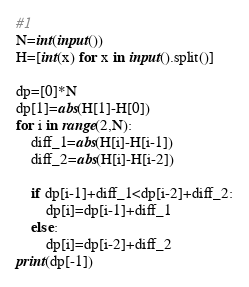<code> <loc_0><loc_0><loc_500><loc_500><_Python_>#1
N=int(input())
H=[int(x) for x in input().split()]

dp=[0]*N
dp[1]=abs(H[1]-H[0])
for i in range(2,N):
    diff_1=abs(H[i]-H[i-1])
    diff_2=abs(H[i]-H[i-2])
    
    if dp[i-1]+diff_1<dp[i-2]+diff_2:
        dp[i]=dp[i-1]+diff_1
    else:
        dp[i]=dp[i-2]+diff_2
print(dp[-1])    </code> 